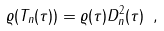Convert formula to latex. <formula><loc_0><loc_0><loc_500><loc_500>\varrho ( T _ { n } ( \tau ) ) = \varrho ( \tau ) D _ { n } ^ { 2 } ( \tau ) \ ,</formula> 